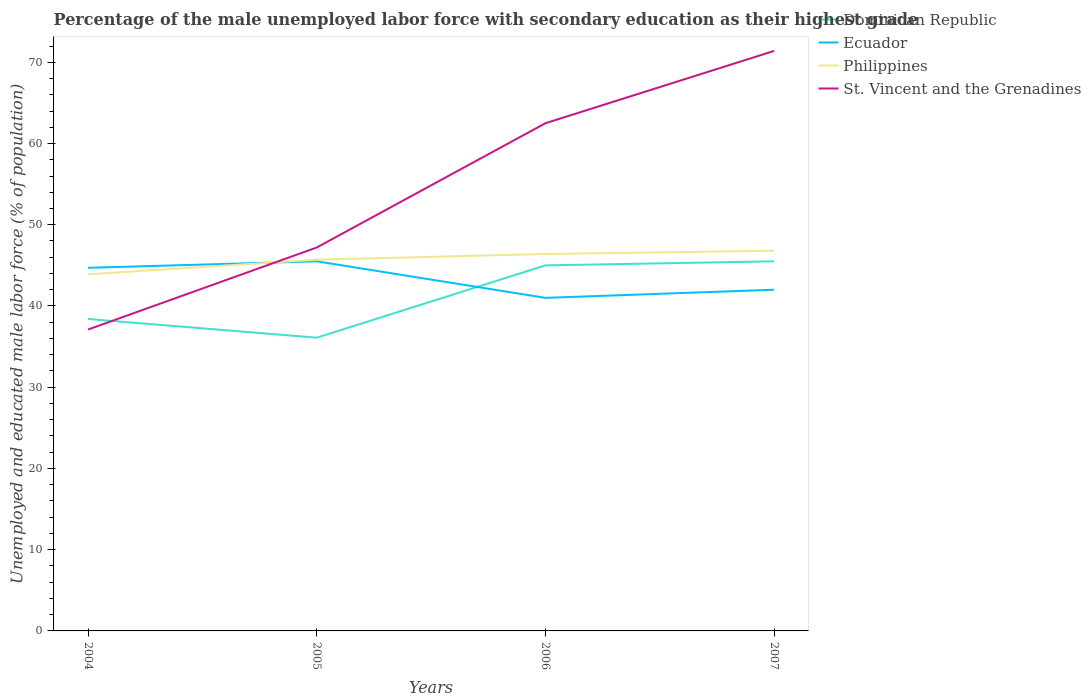How many different coloured lines are there?
Provide a short and direct response. 4. Does the line corresponding to Philippines intersect with the line corresponding to Ecuador?
Ensure brevity in your answer.  Yes. Is the number of lines equal to the number of legend labels?
Give a very brief answer. Yes. Across all years, what is the maximum percentage of the unemployed male labor force with secondary education in Dominican Republic?
Give a very brief answer. 36.1. In which year was the percentage of the unemployed male labor force with secondary education in Ecuador maximum?
Your answer should be very brief. 2006. What is the total percentage of the unemployed male labor force with secondary education in St. Vincent and the Grenadines in the graph?
Keep it short and to the point. -34.3. What is the difference between the highest and the lowest percentage of the unemployed male labor force with secondary education in Philippines?
Give a very brief answer. 3. Is the percentage of the unemployed male labor force with secondary education in St. Vincent and the Grenadines strictly greater than the percentage of the unemployed male labor force with secondary education in Dominican Republic over the years?
Keep it short and to the point. No. How many lines are there?
Ensure brevity in your answer.  4. What is the difference between two consecutive major ticks on the Y-axis?
Make the answer very short. 10. Are the values on the major ticks of Y-axis written in scientific E-notation?
Offer a terse response. No. Does the graph contain any zero values?
Offer a very short reply. No. Does the graph contain grids?
Ensure brevity in your answer.  No. Where does the legend appear in the graph?
Offer a very short reply. Top right. How many legend labels are there?
Make the answer very short. 4. How are the legend labels stacked?
Your response must be concise. Vertical. What is the title of the graph?
Offer a terse response. Percentage of the male unemployed labor force with secondary education as their highest grade. What is the label or title of the Y-axis?
Provide a succinct answer. Unemployed and educated male labor force (% of population). What is the Unemployed and educated male labor force (% of population) of Dominican Republic in 2004?
Make the answer very short. 38.4. What is the Unemployed and educated male labor force (% of population) of Ecuador in 2004?
Offer a terse response. 44.7. What is the Unemployed and educated male labor force (% of population) in Philippines in 2004?
Offer a terse response. 43.9. What is the Unemployed and educated male labor force (% of population) of St. Vincent and the Grenadines in 2004?
Your answer should be very brief. 37.1. What is the Unemployed and educated male labor force (% of population) of Dominican Republic in 2005?
Your answer should be compact. 36.1. What is the Unemployed and educated male labor force (% of population) of Ecuador in 2005?
Offer a terse response. 45.5. What is the Unemployed and educated male labor force (% of population) in Philippines in 2005?
Your answer should be very brief. 45.7. What is the Unemployed and educated male labor force (% of population) in St. Vincent and the Grenadines in 2005?
Keep it short and to the point. 47.2. What is the Unemployed and educated male labor force (% of population) of Dominican Republic in 2006?
Your answer should be very brief. 45. What is the Unemployed and educated male labor force (% of population) in Philippines in 2006?
Offer a terse response. 46.4. What is the Unemployed and educated male labor force (% of population) of St. Vincent and the Grenadines in 2006?
Provide a short and direct response. 62.5. What is the Unemployed and educated male labor force (% of population) in Dominican Republic in 2007?
Offer a very short reply. 45.5. What is the Unemployed and educated male labor force (% of population) in Philippines in 2007?
Your response must be concise. 46.8. What is the Unemployed and educated male labor force (% of population) in St. Vincent and the Grenadines in 2007?
Offer a very short reply. 71.4. Across all years, what is the maximum Unemployed and educated male labor force (% of population) in Dominican Republic?
Ensure brevity in your answer.  45.5. Across all years, what is the maximum Unemployed and educated male labor force (% of population) in Ecuador?
Give a very brief answer. 45.5. Across all years, what is the maximum Unemployed and educated male labor force (% of population) of Philippines?
Give a very brief answer. 46.8. Across all years, what is the maximum Unemployed and educated male labor force (% of population) in St. Vincent and the Grenadines?
Your response must be concise. 71.4. Across all years, what is the minimum Unemployed and educated male labor force (% of population) in Dominican Republic?
Give a very brief answer. 36.1. Across all years, what is the minimum Unemployed and educated male labor force (% of population) in Philippines?
Make the answer very short. 43.9. Across all years, what is the minimum Unemployed and educated male labor force (% of population) in St. Vincent and the Grenadines?
Ensure brevity in your answer.  37.1. What is the total Unemployed and educated male labor force (% of population) in Dominican Republic in the graph?
Offer a terse response. 165. What is the total Unemployed and educated male labor force (% of population) of Ecuador in the graph?
Your answer should be very brief. 173.2. What is the total Unemployed and educated male labor force (% of population) of Philippines in the graph?
Offer a terse response. 182.8. What is the total Unemployed and educated male labor force (% of population) of St. Vincent and the Grenadines in the graph?
Provide a succinct answer. 218.2. What is the difference between the Unemployed and educated male labor force (% of population) of Ecuador in 2004 and that in 2006?
Your answer should be compact. 3.7. What is the difference between the Unemployed and educated male labor force (% of population) in St. Vincent and the Grenadines in 2004 and that in 2006?
Your answer should be very brief. -25.4. What is the difference between the Unemployed and educated male labor force (% of population) in Ecuador in 2004 and that in 2007?
Your answer should be compact. 2.7. What is the difference between the Unemployed and educated male labor force (% of population) of St. Vincent and the Grenadines in 2004 and that in 2007?
Make the answer very short. -34.3. What is the difference between the Unemployed and educated male labor force (% of population) of Dominican Republic in 2005 and that in 2006?
Your response must be concise. -8.9. What is the difference between the Unemployed and educated male labor force (% of population) of Ecuador in 2005 and that in 2006?
Ensure brevity in your answer.  4.5. What is the difference between the Unemployed and educated male labor force (% of population) in St. Vincent and the Grenadines in 2005 and that in 2006?
Offer a very short reply. -15.3. What is the difference between the Unemployed and educated male labor force (% of population) of Dominican Republic in 2005 and that in 2007?
Make the answer very short. -9.4. What is the difference between the Unemployed and educated male labor force (% of population) of St. Vincent and the Grenadines in 2005 and that in 2007?
Keep it short and to the point. -24.2. What is the difference between the Unemployed and educated male labor force (% of population) in Dominican Republic in 2006 and that in 2007?
Offer a very short reply. -0.5. What is the difference between the Unemployed and educated male labor force (% of population) of St. Vincent and the Grenadines in 2006 and that in 2007?
Your response must be concise. -8.9. What is the difference between the Unemployed and educated male labor force (% of population) in Dominican Republic in 2004 and the Unemployed and educated male labor force (% of population) in Ecuador in 2005?
Give a very brief answer. -7.1. What is the difference between the Unemployed and educated male labor force (% of population) of Dominican Republic in 2004 and the Unemployed and educated male labor force (% of population) of St. Vincent and the Grenadines in 2005?
Your response must be concise. -8.8. What is the difference between the Unemployed and educated male labor force (% of population) of Dominican Republic in 2004 and the Unemployed and educated male labor force (% of population) of Philippines in 2006?
Make the answer very short. -8. What is the difference between the Unemployed and educated male labor force (% of population) of Dominican Republic in 2004 and the Unemployed and educated male labor force (% of population) of St. Vincent and the Grenadines in 2006?
Your answer should be very brief. -24.1. What is the difference between the Unemployed and educated male labor force (% of population) of Ecuador in 2004 and the Unemployed and educated male labor force (% of population) of Philippines in 2006?
Ensure brevity in your answer.  -1.7. What is the difference between the Unemployed and educated male labor force (% of population) of Ecuador in 2004 and the Unemployed and educated male labor force (% of population) of St. Vincent and the Grenadines in 2006?
Your response must be concise. -17.8. What is the difference between the Unemployed and educated male labor force (% of population) in Philippines in 2004 and the Unemployed and educated male labor force (% of population) in St. Vincent and the Grenadines in 2006?
Make the answer very short. -18.6. What is the difference between the Unemployed and educated male labor force (% of population) of Dominican Republic in 2004 and the Unemployed and educated male labor force (% of population) of Ecuador in 2007?
Offer a very short reply. -3.6. What is the difference between the Unemployed and educated male labor force (% of population) of Dominican Republic in 2004 and the Unemployed and educated male labor force (% of population) of St. Vincent and the Grenadines in 2007?
Your answer should be very brief. -33. What is the difference between the Unemployed and educated male labor force (% of population) in Ecuador in 2004 and the Unemployed and educated male labor force (% of population) in Philippines in 2007?
Your answer should be compact. -2.1. What is the difference between the Unemployed and educated male labor force (% of population) in Ecuador in 2004 and the Unemployed and educated male labor force (% of population) in St. Vincent and the Grenadines in 2007?
Your answer should be compact. -26.7. What is the difference between the Unemployed and educated male labor force (% of population) in Philippines in 2004 and the Unemployed and educated male labor force (% of population) in St. Vincent and the Grenadines in 2007?
Provide a short and direct response. -27.5. What is the difference between the Unemployed and educated male labor force (% of population) of Dominican Republic in 2005 and the Unemployed and educated male labor force (% of population) of Ecuador in 2006?
Ensure brevity in your answer.  -4.9. What is the difference between the Unemployed and educated male labor force (% of population) of Dominican Republic in 2005 and the Unemployed and educated male labor force (% of population) of St. Vincent and the Grenadines in 2006?
Your answer should be compact. -26.4. What is the difference between the Unemployed and educated male labor force (% of population) of Ecuador in 2005 and the Unemployed and educated male labor force (% of population) of St. Vincent and the Grenadines in 2006?
Keep it short and to the point. -17. What is the difference between the Unemployed and educated male labor force (% of population) in Philippines in 2005 and the Unemployed and educated male labor force (% of population) in St. Vincent and the Grenadines in 2006?
Keep it short and to the point. -16.8. What is the difference between the Unemployed and educated male labor force (% of population) in Dominican Republic in 2005 and the Unemployed and educated male labor force (% of population) in Philippines in 2007?
Keep it short and to the point. -10.7. What is the difference between the Unemployed and educated male labor force (% of population) of Dominican Republic in 2005 and the Unemployed and educated male labor force (% of population) of St. Vincent and the Grenadines in 2007?
Your answer should be compact. -35.3. What is the difference between the Unemployed and educated male labor force (% of population) of Ecuador in 2005 and the Unemployed and educated male labor force (% of population) of St. Vincent and the Grenadines in 2007?
Give a very brief answer. -25.9. What is the difference between the Unemployed and educated male labor force (% of population) of Philippines in 2005 and the Unemployed and educated male labor force (% of population) of St. Vincent and the Grenadines in 2007?
Your answer should be very brief. -25.7. What is the difference between the Unemployed and educated male labor force (% of population) of Dominican Republic in 2006 and the Unemployed and educated male labor force (% of population) of Ecuador in 2007?
Ensure brevity in your answer.  3. What is the difference between the Unemployed and educated male labor force (% of population) in Dominican Republic in 2006 and the Unemployed and educated male labor force (% of population) in Philippines in 2007?
Offer a very short reply. -1.8. What is the difference between the Unemployed and educated male labor force (% of population) of Dominican Republic in 2006 and the Unemployed and educated male labor force (% of population) of St. Vincent and the Grenadines in 2007?
Provide a short and direct response. -26.4. What is the difference between the Unemployed and educated male labor force (% of population) of Ecuador in 2006 and the Unemployed and educated male labor force (% of population) of Philippines in 2007?
Make the answer very short. -5.8. What is the difference between the Unemployed and educated male labor force (% of population) in Ecuador in 2006 and the Unemployed and educated male labor force (% of population) in St. Vincent and the Grenadines in 2007?
Make the answer very short. -30.4. What is the difference between the Unemployed and educated male labor force (% of population) in Philippines in 2006 and the Unemployed and educated male labor force (% of population) in St. Vincent and the Grenadines in 2007?
Make the answer very short. -25. What is the average Unemployed and educated male labor force (% of population) in Dominican Republic per year?
Ensure brevity in your answer.  41.25. What is the average Unemployed and educated male labor force (% of population) of Ecuador per year?
Keep it short and to the point. 43.3. What is the average Unemployed and educated male labor force (% of population) of Philippines per year?
Offer a terse response. 45.7. What is the average Unemployed and educated male labor force (% of population) of St. Vincent and the Grenadines per year?
Keep it short and to the point. 54.55. In the year 2004, what is the difference between the Unemployed and educated male labor force (% of population) in Dominican Republic and Unemployed and educated male labor force (% of population) in Ecuador?
Make the answer very short. -6.3. In the year 2004, what is the difference between the Unemployed and educated male labor force (% of population) of Dominican Republic and Unemployed and educated male labor force (% of population) of St. Vincent and the Grenadines?
Make the answer very short. 1.3. In the year 2004, what is the difference between the Unemployed and educated male labor force (% of population) of Ecuador and Unemployed and educated male labor force (% of population) of Philippines?
Your answer should be very brief. 0.8. In the year 2004, what is the difference between the Unemployed and educated male labor force (% of population) of Ecuador and Unemployed and educated male labor force (% of population) of St. Vincent and the Grenadines?
Ensure brevity in your answer.  7.6. In the year 2005, what is the difference between the Unemployed and educated male labor force (% of population) in Dominican Republic and Unemployed and educated male labor force (% of population) in Philippines?
Make the answer very short. -9.6. In the year 2005, what is the difference between the Unemployed and educated male labor force (% of population) in Dominican Republic and Unemployed and educated male labor force (% of population) in St. Vincent and the Grenadines?
Offer a very short reply. -11.1. In the year 2006, what is the difference between the Unemployed and educated male labor force (% of population) of Dominican Republic and Unemployed and educated male labor force (% of population) of Ecuador?
Your answer should be very brief. 4. In the year 2006, what is the difference between the Unemployed and educated male labor force (% of population) in Dominican Republic and Unemployed and educated male labor force (% of population) in St. Vincent and the Grenadines?
Your response must be concise. -17.5. In the year 2006, what is the difference between the Unemployed and educated male labor force (% of population) in Ecuador and Unemployed and educated male labor force (% of population) in St. Vincent and the Grenadines?
Provide a short and direct response. -21.5. In the year 2006, what is the difference between the Unemployed and educated male labor force (% of population) in Philippines and Unemployed and educated male labor force (% of population) in St. Vincent and the Grenadines?
Your response must be concise. -16.1. In the year 2007, what is the difference between the Unemployed and educated male labor force (% of population) of Dominican Republic and Unemployed and educated male labor force (% of population) of Philippines?
Provide a short and direct response. -1.3. In the year 2007, what is the difference between the Unemployed and educated male labor force (% of population) in Dominican Republic and Unemployed and educated male labor force (% of population) in St. Vincent and the Grenadines?
Your response must be concise. -25.9. In the year 2007, what is the difference between the Unemployed and educated male labor force (% of population) in Ecuador and Unemployed and educated male labor force (% of population) in Philippines?
Your answer should be compact. -4.8. In the year 2007, what is the difference between the Unemployed and educated male labor force (% of population) of Ecuador and Unemployed and educated male labor force (% of population) of St. Vincent and the Grenadines?
Offer a terse response. -29.4. In the year 2007, what is the difference between the Unemployed and educated male labor force (% of population) of Philippines and Unemployed and educated male labor force (% of population) of St. Vincent and the Grenadines?
Your answer should be very brief. -24.6. What is the ratio of the Unemployed and educated male labor force (% of population) of Dominican Republic in 2004 to that in 2005?
Your answer should be compact. 1.06. What is the ratio of the Unemployed and educated male labor force (% of population) in Ecuador in 2004 to that in 2005?
Give a very brief answer. 0.98. What is the ratio of the Unemployed and educated male labor force (% of population) in Philippines in 2004 to that in 2005?
Make the answer very short. 0.96. What is the ratio of the Unemployed and educated male labor force (% of population) in St. Vincent and the Grenadines in 2004 to that in 2005?
Keep it short and to the point. 0.79. What is the ratio of the Unemployed and educated male labor force (% of population) in Dominican Republic in 2004 to that in 2006?
Offer a terse response. 0.85. What is the ratio of the Unemployed and educated male labor force (% of population) of Ecuador in 2004 to that in 2006?
Ensure brevity in your answer.  1.09. What is the ratio of the Unemployed and educated male labor force (% of population) of Philippines in 2004 to that in 2006?
Keep it short and to the point. 0.95. What is the ratio of the Unemployed and educated male labor force (% of population) in St. Vincent and the Grenadines in 2004 to that in 2006?
Your response must be concise. 0.59. What is the ratio of the Unemployed and educated male labor force (% of population) in Dominican Republic in 2004 to that in 2007?
Offer a terse response. 0.84. What is the ratio of the Unemployed and educated male labor force (% of population) in Ecuador in 2004 to that in 2007?
Make the answer very short. 1.06. What is the ratio of the Unemployed and educated male labor force (% of population) of Philippines in 2004 to that in 2007?
Give a very brief answer. 0.94. What is the ratio of the Unemployed and educated male labor force (% of population) in St. Vincent and the Grenadines in 2004 to that in 2007?
Your answer should be very brief. 0.52. What is the ratio of the Unemployed and educated male labor force (% of population) of Dominican Republic in 2005 to that in 2006?
Offer a terse response. 0.8. What is the ratio of the Unemployed and educated male labor force (% of population) of Ecuador in 2005 to that in 2006?
Keep it short and to the point. 1.11. What is the ratio of the Unemployed and educated male labor force (% of population) of Philippines in 2005 to that in 2006?
Provide a short and direct response. 0.98. What is the ratio of the Unemployed and educated male labor force (% of population) in St. Vincent and the Grenadines in 2005 to that in 2006?
Offer a terse response. 0.76. What is the ratio of the Unemployed and educated male labor force (% of population) of Dominican Republic in 2005 to that in 2007?
Provide a short and direct response. 0.79. What is the ratio of the Unemployed and educated male labor force (% of population) in Ecuador in 2005 to that in 2007?
Offer a very short reply. 1.08. What is the ratio of the Unemployed and educated male labor force (% of population) of Philippines in 2005 to that in 2007?
Ensure brevity in your answer.  0.98. What is the ratio of the Unemployed and educated male labor force (% of population) of St. Vincent and the Grenadines in 2005 to that in 2007?
Your response must be concise. 0.66. What is the ratio of the Unemployed and educated male labor force (% of population) of Dominican Republic in 2006 to that in 2007?
Make the answer very short. 0.99. What is the ratio of the Unemployed and educated male labor force (% of population) in Ecuador in 2006 to that in 2007?
Your answer should be compact. 0.98. What is the ratio of the Unemployed and educated male labor force (% of population) of Philippines in 2006 to that in 2007?
Your answer should be very brief. 0.99. What is the ratio of the Unemployed and educated male labor force (% of population) in St. Vincent and the Grenadines in 2006 to that in 2007?
Your answer should be very brief. 0.88. What is the difference between the highest and the second highest Unemployed and educated male labor force (% of population) of Philippines?
Offer a terse response. 0.4. What is the difference between the highest and the lowest Unemployed and educated male labor force (% of population) in Dominican Republic?
Make the answer very short. 9.4. What is the difference between the highest and the lowest Unemployed and educated male labor force (% of population) in Ecuador?
Give a very brief answer. 4.5. What is the difference between the highest and the lowest Unemployed and educated male labor force (% of population) in St. Vincent and the Grenadines?
Offer a very short reply. 34.3. 